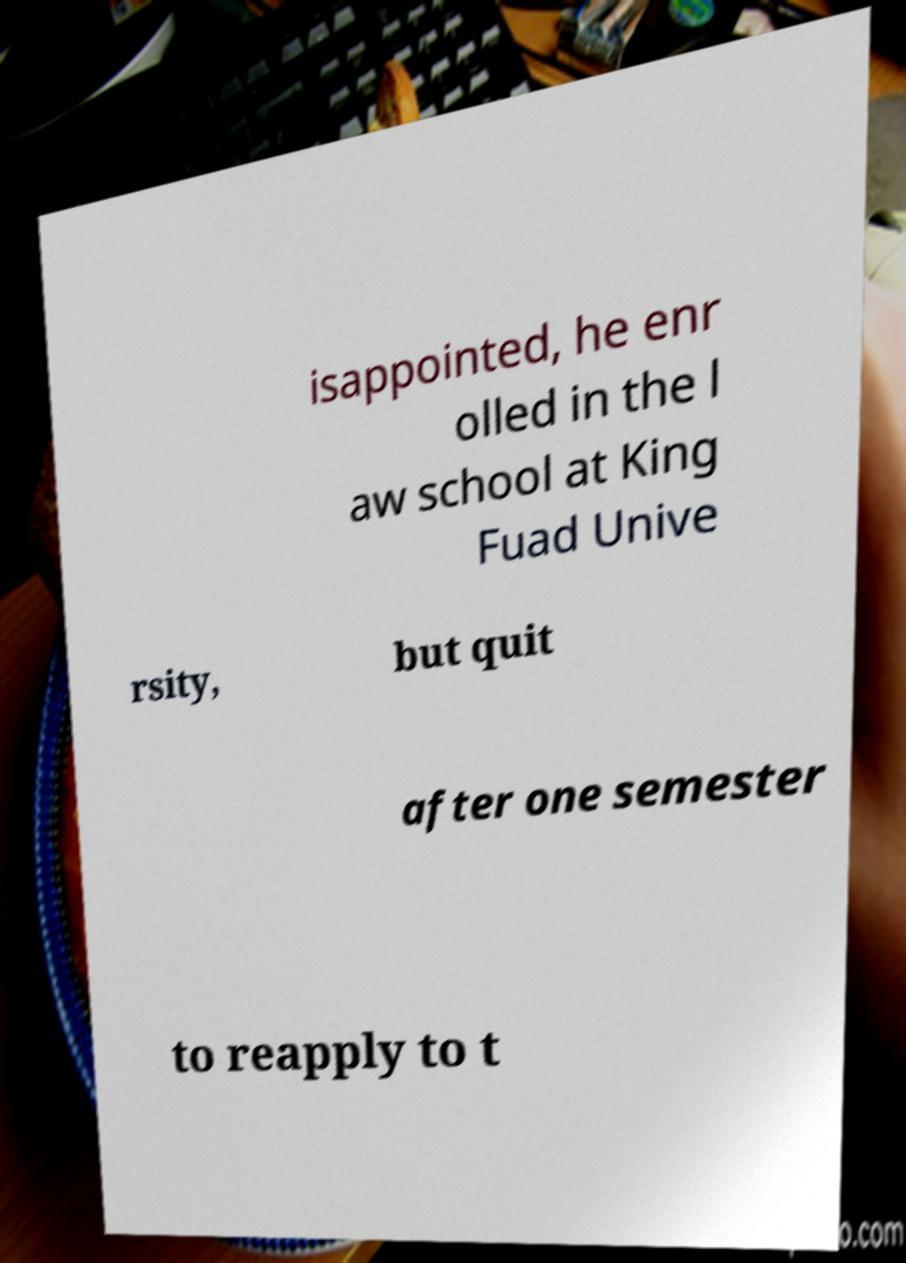Can you accurately transcribe the text from the provided image for me? isappointed, he enr olled in the l aw school at King Fuad Unive rsity, but quit after one semester to reapply to t 